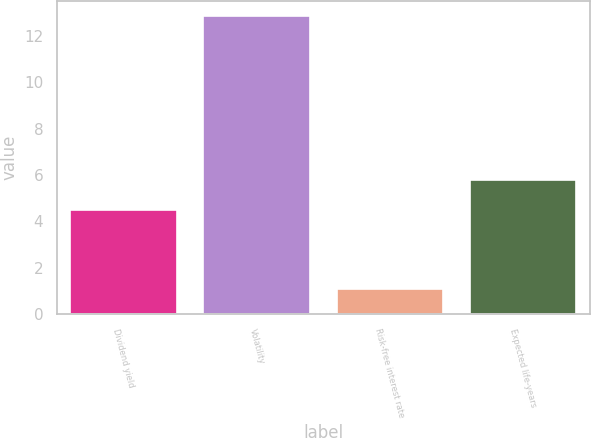Convert chart. <chart><loc_0><loc_0><loc_500><loc_500><bar_chart><fcel>Dividend yield<fcel>Volatility<fcel>Risk-free interest rate<fcel>Expected life-years<nl><fcel>4.5<fcel>12.86<fcel>1.08<fcel>5.8<nl></chart> 